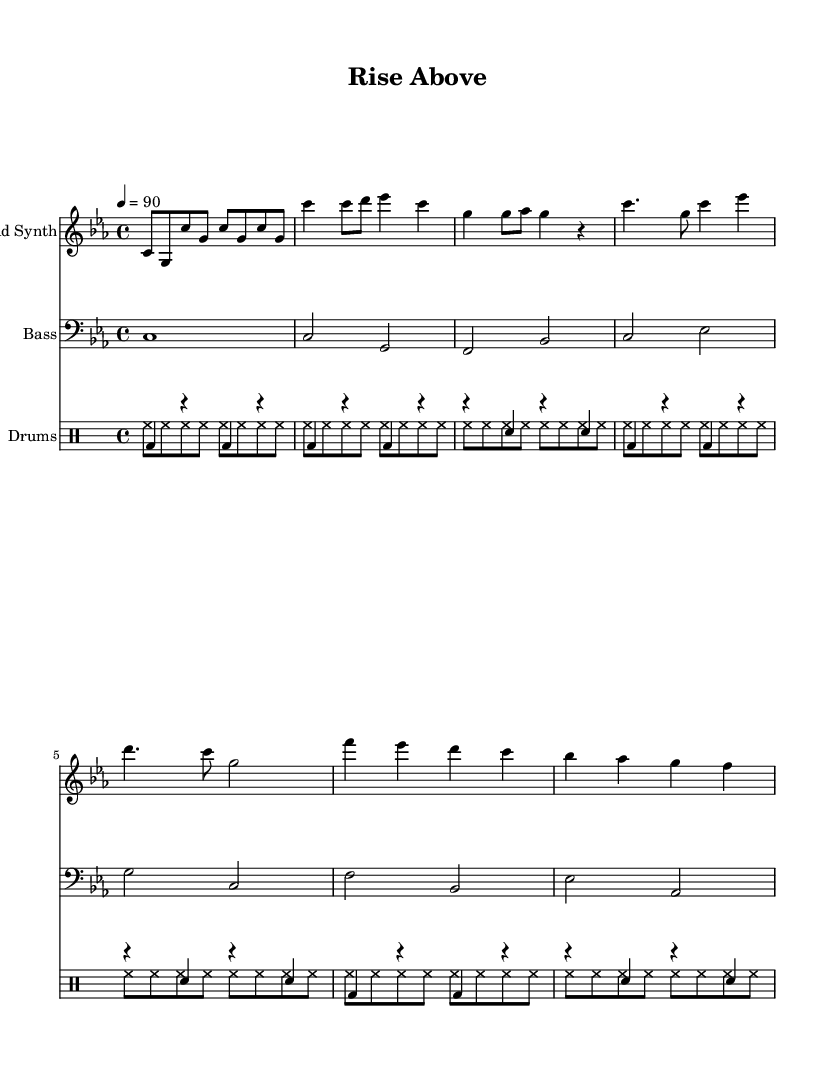What is the key signature of this music? The key signature is indicated at the beginning of the staff. In this case, it shows 3 flats, which corresponds to C minor.
Answer: C minor What is the time signature of this music? The time signature is found at the start of the piece and shows 4 beats per measure, indicated by the notation 4/4.
Answer: 4/4 What is the tempo marking for this music? The tempo marking indicates the speed of the piece, which is set at 90 beats per minute as stated in the score.
Answer: 90 How many measures are in the chorus section? By counting the measures in the chorus, which lasts for the indicated part, there are a total of 4 measures included in this section.
Answer: 4 What instrument plays the lead synth part? The instrument name is specified at the beginning of the corresponding staff, which states that the part is for "Lead Synth."
Answer: Lead Synth Which parts are included in the verse section? The verse contains a specific pattern of notes for both the lead synth and bass, but the primary elements are the notes that correspond to the verse section in the score. The answer would include the notes played by the lead synth and bass during this segment.
Answer: Lead Synth and Bass 